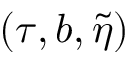Convert formula to latex. <formula><loc_0><loc_0><loc_500><loc_500>( \tau , b , \tilde { \eta } )</formula> 